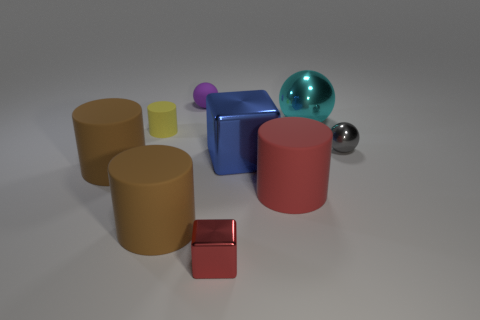There is a cylinder that is behind the gray shiny object behind the tiny red shiny block; what size is it?
Your response must be concise. Small. Is there a cylinder that has the same color as the tiny cube?
Make the answer very short. Yes. Does the tiny metallic object left of the large cyan object have the same color as the big matte cylinder that is on the right side of the tiny purple sphere?
Keep it short and to the point. Yes. There is a big blue thing; what shape is it?
Your answer should be compact. Cube. There is a red block; how many large cylinders are on the right side of it?
Your answer should be compact. 1. What number of brown cylinders are the same material as the tiny purple thing?
Keep it short and to the point. 2. Is the tiny sphere that is in front of the small purple rubber sphere made of the same material as the small cylinder?
Offer a very short reply. No. Are there any large cyan objects?
Provide a short and direct response. Yes. There is a thing that is right of the yellow object and left of the tiny purple matte sphere; how big is it?
Make the answer very short. Large. Is the number of large brown rubber cylinders that are on the right side of the yellow matte cylinder greater than the number of tiny red metallic objects that are on the right side of the blue thing?
Your answer should be very brief. Yes. 